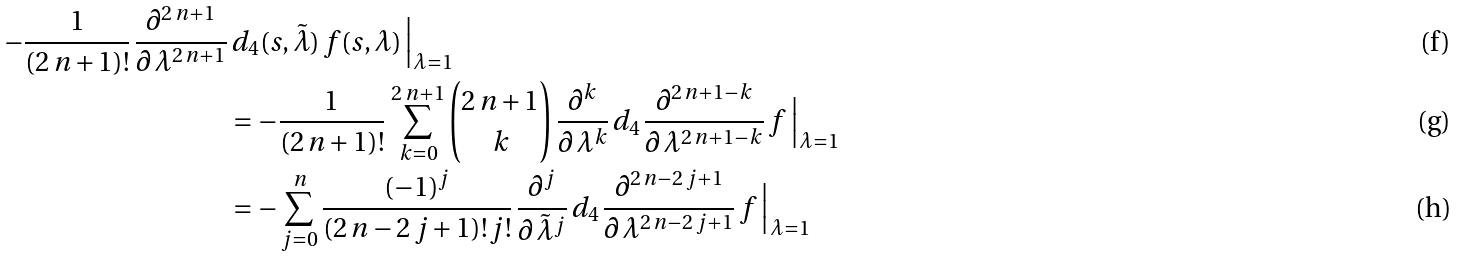Convert formula to latex. <formula><loc_0><loc_0><loc_500><loc_500>- \frac { 1 } { ( 2 \, n + 1 ) ! } \, \frac { \partial ^ { 2 \, n + 1 } } { \partial \, \lambda ^ { 2 \, n + 1 } } & \, d _ { 4 } ( s , \tilde { \lambda } ) \, f ( s , \lambda ) \, \Big { | } _ { \lambda = 1 } \\ & = - \frac { 1 } { ( 2 \, n + 1 ) ! } \, \sum _ { k = 0 } ^ { 2 \, n + 1 } \binom { 2 \, n + 1 } { k } \, \frac { \partial ^ { k } } { \partial \, \lambda ^ { k } } \, d _ { 4 \, } \frac { \partial ^ { 2 \, n + 1 - k } } { \partial \, \lambda ^ { 2 \, n + 1 - k } } \, f \, \Big { | } _ { \lambda = 1 } \\ & = - \sum _ { j = 0 } ^ { n } \frac { ( - 1 ) ^ { j } } { ( 2 \, n - 2 \, j + 1 ) ! \, j ! } \, \frac { \partial ^ { j } } { \partial \, \tilde { \lambda } ^ { j } } \, d _ { 4 \, } \frac { \partial ^ { 2 \, n - 2 \, j + 1 } } { \partial \, \lambda ^ { 2 \, n - 2 \, j + 1 } } \, f \, \Big { | } _ { \lambda = 1 }</formula> 